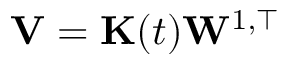<formula> <loc_0><loc_0><loc_500><loc_500>V = K ( t ) W ^ { 1 , \top }</formula> 